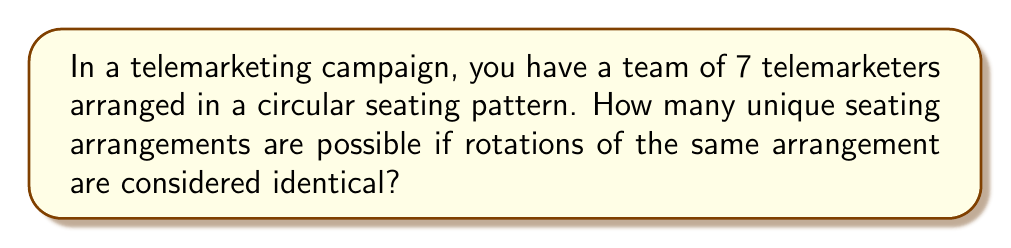Give your solution to this math problem. To solve this problem, we need to consider the properties of cyclic groups and permutations:

1) First, we start with the total number of permutations for 7 people, which is 7! (7 factorial).

2) However, in a cyclic group, rotations of the same arrangement are considered identical. This means that for each unique arrangement, there are 7 rotations that are considered the same.

3) To account for this, we need to divide the total number of permutations by the number of elements in the cyclic group (which is 7 in this case).

4) The formula for the number of unique permutations in a cyclic group is:

   $$(n-1)!$$

   Where n is the number of elements in the group.

5) In this case, n = 7, so we calculate:

   $$(7-1)! = 6! = 6 \times 5 \times 4 \times 3 \times 2 \times 1 = 720$$

Therefore, there are 720 unique seating arrangements for the 7 telemarketers in a circular pattern.

This result is particularly useful for a marketing director as it represents the number of unique team configurations that could potentially affect the dynamics and performance of the telemarketing team.
Answer: 720 unique seating arrangements 